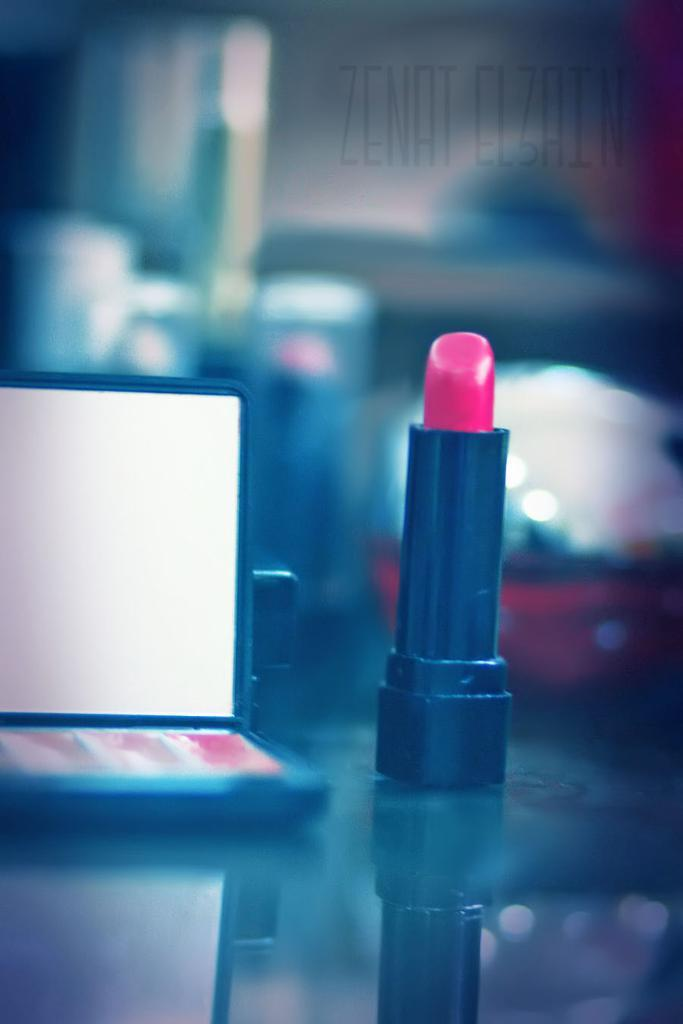What object is present in the image? There is a lipstick in the image. What color is the lipstick? The lipstick is pink in color. How many tomatoes are on the marble counter in the image? There is no marble counter or tomatoes present in the image; it only features a pink lipstick. 